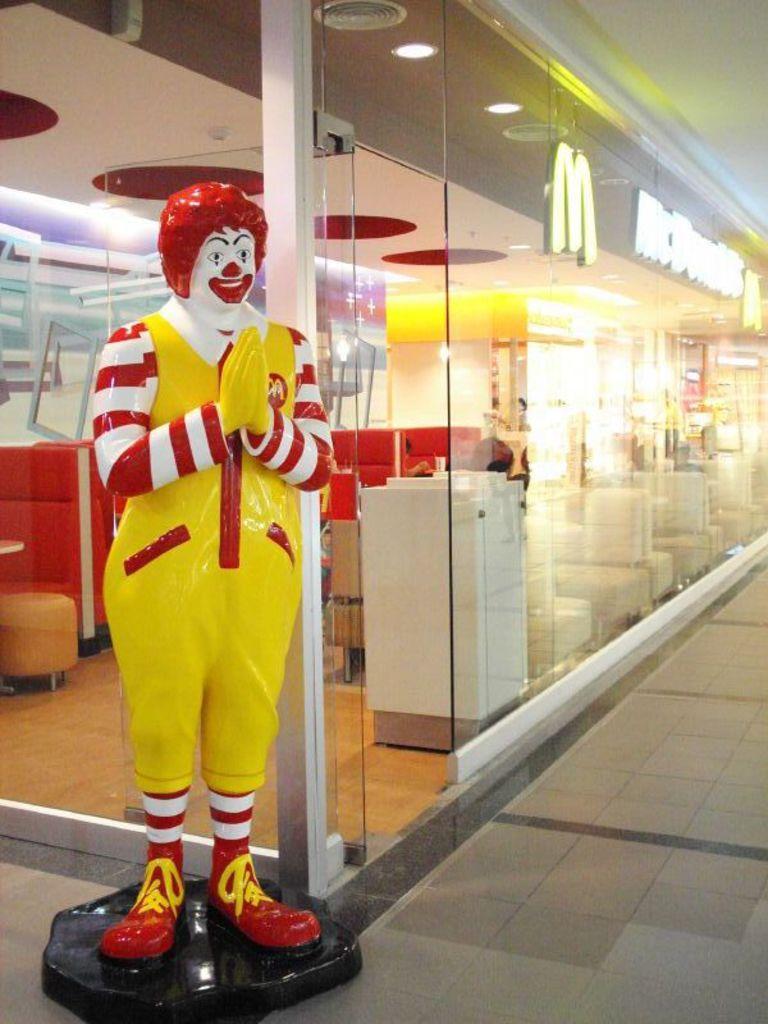How would you summarize this image in a sentence or two? In the center of the image, we can see one doll with different colors. In the background there is a building, wall, roof, glass, banner, fridge, tables, sofas, stools, lights and a few other objects. 